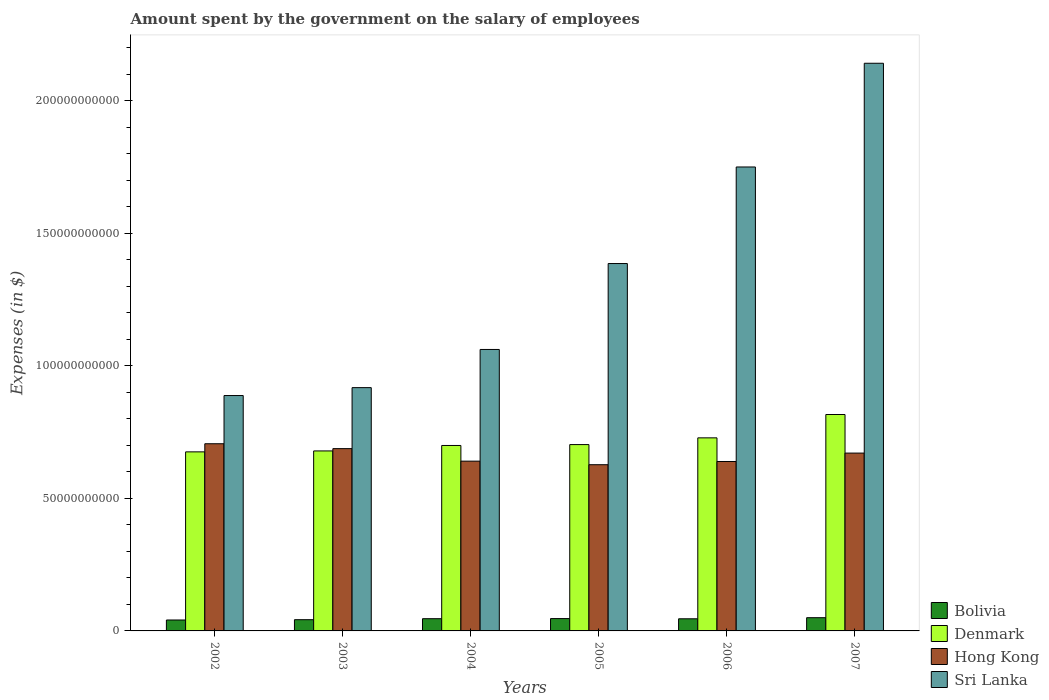Are the number of bars per tick equal to the number of legend labels?
Provide a short and direct response. Yes. Are the number of bars on each tick of the X-axis equal?
Your answer should be compact. Yes. How many bars are there on the 4th tick from the left?
Offer a very short reply. 4. How many bars are there on the 2nd tick from the right?
Offer a very short reply. 4. What is the label of the 5th group of bars from the left?
Your answer should be compact. 2006. In how many cases, is the number of bars for a given year not equal to the number of legend labels?
Give a very brief answer. 0. What is the amount spent on the salary of employees by the government in Denmark in 2006?
Make the answer very short. 7.28e+1. Across all years, what is the maximum amount spent on the salary of employees by the government in Bolivia?
Your response must be concise. 4.99e+09. Across all years, what is the minimum amount spent on the salary of employees by the government in Bolivia?
Your answer should be compact. 4.12e+09. What is the total amount spent on the salary of employees by the government in Hong Kong in the graph?
Keep it short and to the point. 3.97e+11. What is the difference between the amount spent on the salary of employees by the government in Bolivia in 2002 and that in 2007?
Give a very brief answer. -8.69e+08. What is the difference between the amount spent on the salary of employees by the government in Denmark in 2005 and the amount spent on the salary of employees by the government in Sri Lanka in 2004?
Your response must be concise. -3.59e+1. What is the average amount spent on the salary of employees by the government in Hong Kong per year?
Provide a short and direct response. 6.62e+1. In the year 2003, what is the difference between the amount spent on the salary of employees by the government in Denmark and amount spent on the salary of employees by the government in Hong Kong?
Ensure brevity in your answer.  -8.68e+08. In how many years, is the amount spent on the salary of employees by the government in Sri Lanka greater than 120000000000 $?
Offer a very short reply. 3. What is the ratio of the amount spent on the salary of employees by the government in Sri Lanka in 2003 to that in 2007?
Your answer should be compact. 0.43. Is the amount spent on the salary of employees by the government in Denmark in 2003 less than that in 2005?
Keep it short and to the point. Yes. What is the difference between the highest and the second highest amount spent on the salary of employees by the government in Denmark?
Give a very brief answer. 8.81e+09. What is the difference between the highest and the lowest amount spent on the salary of employees by the government in Hong Kong?
Keep it short and to the point. 7.91e+09. Is it the case that in every year, the sum of the amount spent on the salary of employees by the government in Sri Lanka and amount spent on the salary of employees by the government in Denmark is greater than the sum of amount spent on the salary of employees by the government in Bolivia and amount spent on the salary of employees by the government in Hong Kong?
Give a very brief answer. Yes. What does the 3rd bar from the right in 2003 represents?
Offer a terse response. Denmark. Is it the case that in every year, the sum of the amount spent on the salary of employees by the government in Bolivia and amount spent on the salary of employees by the government in Denmark is greater than the amount spent on the salary of employees by the government in Sri Lanka?
Make the answer very short. No. How many bars are there?
Offer a terse response. 24. Does the graph contain any zero values?
Your answer should be compact. No. Does the graph contain grids?
Provide a short and direct response. No. How many legend labels are there?
Offer a very short reply. 4. What is the title of the graph?
Your answer should be compact. Amount spent by the government on the salary of employees. What is the label or title of the Y-axis?
Keep it short and to the point. Expenses (in $). What is the Expenses (in $) of Bolivia in 2002?
Keep it short and to the point. 4.12e+09. What is the Expenses (in $) in Denmark in 2002?
Make the answer very short. 6.76e+1. What is the Expenses (in $) in Hong Kong in 2002?
Make the answer very short. 7.06e+1. What is the Expenses (in $) of Sri Lanka in 2002?
Your answer should be very brief. 8.88e+1. What is the Expenses (in $) in Bolivia in 2003?
Your answer should be compact. 4.24e+09. What is the Expenses (in $) of Denmark in 2003?
Provide a succinct answer. 6.79e+1. What is the Expenses (in $) in Hong Kong in 2003?
Your answer should be compact. 6.88e+1. What is the Expenses (in $) of Sri Lanka in 2003?
Your response must be concise. 9.18e+1. What is the Expenses (in $) in Bolivia in 2004?
Give a very brief answer. 4.61e+09. What is the Expenses (in $) of Denmark in 2004?
Ensure brevity in your answer.  7.00e+1. What is the Expenses (in $) of Hong Kong in 2004?
Ensure brevity in your answer.  6.41e+1. What is the Expenses (in $) in Sri Lanka in 2004?
Provide a succinct answer. 1.06e+11. What is the Expenses (in $) of Bolivia in 2005?
Your answer should be compact. 4.65e+09. What is the Expenses (in $) in Denmark in 2005?
Offer a terse response. 7.03e+1. What is the Expenses (in $) in Hong Kong in 2005?
Offer a terse response. 6.27e+1. What is the Expenses (in $) of Sri Lanka in 2005?
Give a very brief answer. 1.39e+11. What is the Expenses (in $) of Bolivia in 2006?
Offer a terse response. 4.57e+09. What is the Expenses (in $) of Denmark in 2006?
Offer a terse response. 7.28e+1. What is the Expenses (in $) in Hong Kong in 2006?
Provide a short and direct response. 6.39e+1. What is the Expenses (in $) in Sri Lanka in 2006?
Provide a succinct answer. 1.75e+11. What is the Expenses (in $) in Bolivia in 2007?
Your answer should be compact. 4.99e+09. What is the Expenses (in $) of Denmark in 2007?
Provide a short and direct response. 8.16e+1. What is the Expenses (in $) in Hong Kong in 2007?
Make the answer very short. 6.71e+1. What is the Expenses (in $) of Sri Lanka in 2007?
Provide a short and direct response. 2.14e+11. Across all years, what is the maximum Expenses (in $) in Bolivia?
Offer a terse response. 4.99e+09. Across all years, what is the maximum Expenses (in $) of Denmark?
Your answer should be compact. 8.16e+1. Across all years, what is the maximum Expenses (in $) in Hong Kong?
Your answer should be compact. 7.06e+1. Across all years, what is the maximum Expenses (in $) of Sri Lanka?
Offer a terse response. 2.14e+11. Across all years, what is the minimum Expenses (in $) of Bolivia?
Give a very brief answer. 4.12e+09. Across all years, what is the minimum Expenses (in $) in Denmark?
Ensure brevity in your answer.  6.76e+1. Across all years, what is the minimum Expenses (in $) in Hong Kong?
Offer a terse response. 6.27e+1. Across all years, what is the minimum Expenses (in $) of Sri Lanka?
Give a very brief answer. 8.88e+1. What is the total Expenses (in $) in Bolivia in the graph?
Your response must be concise. 2.72e+1. What is the total Expenses (in $) of Denmark in the graph?
Offer a very short reply. 4.30e+11. What is the total Expenses (in $) in Hong Kong in the graph?
Your answer should be very brief. 3.97e+11. What is the total Expenses (in $) in Sri Lanka in the graph?
Ensure brevity in your answer.  8.15e+11. What is the difference between the Expenses (in $) in Bolivia in 2002 and that in 2003?
Your answer should be compact. -1.16e+08. What is the difference between the Expenses (in $) of Denmark in 2002 and that in 2003?
Your answer should be compact. -3.53e+08. What is the difference between the Expenses (in $) of Hong Kong in 2002 and that in 2003?
Offer a terse response. 1.84e+09. What is the difference between the Expenses (in $) in Sri Lanka in 2002 and that in 2003?
Offer a terse response. -2.98e+09. What is the difference between the Expenses (in $) of Bolivia in 2002 and that in 2004?
Provide a short and direct response. -4.90e+08. What is the difference between the Expenses (in $) of Denmark in 2002 and that in 2004?
Keep it short and to the point. -2.41e+09. What is the difference between the Expenses (in $) of Hong Kong in 2002 and that in 2004?
Provide a succinct answer. 6.56e+09. What is the difference between the Expenses (in $) in Sri Lanka in 2002 and that in 2004?
Offer a very short reply. -1.74e+1. What is the difference between the Expenses (in $) in Bolivia in 2002 and that in 2005?
Ensure brevity in your answer.  -5.32e+08. What is the difference between the Expenses (in $) of Denmark in 2002 and that in 2005?
Your answer should be very brief. -2.75e+09. What is the difference between the Expenses (in $) in Hong Kong in 2002 and that in 2005?
Your answer should be very brief. 7.91e+09. What is the difference between the Expenses (in $) of Sri Lanka in 2002 and that in 2005?
Provide a succinct answer. -4.98e+1. What is the difference between the Expenses (in $) in Bolivia in 2002 and that in 2006?
Your response must be concise. -4.53e+08. What is the difference between the Expenses (in $) of Denmark in 2002 and that in 2006?
Provide a short and direct response. -5.29e+09. What is the difference between the Expenses (in $) in Hong Kong in 2002 and that in 2006?
Offer a very short reply. 6.70e+09. What is the difference between the Expenses (in $) of Sri Lanka in 2002 and that in 2006?
Ensure brevity in your answer.  -8.62e+1. What is the difference between the Expenses (in $) of Bolivia in 2002 and that in 2007?
Offer a terse response. -8.69e+08. What is the difference between the Expenses (in $) of Denmark in 2002 and that in 2007?
Your response must be concise. -1.41e+1. What is the difference between the Expenses (in $) of Hong Kong in 2002 and that in 2007?
Ensure brevity in your answer.  3.52e+09. What is the difference between the Expenses (in $) in Sri Lanka in 2002 and that in 2007?
Your answer should be very brief. -1.25e+11. What is the difference between the Expenses (in $) in Bolivia in 2003 and that in 2004?
Your answer should be compact. -3.74e+08. What is the difference between the Expenses (in $) of Denmark in 2003 and that in 2004?
Your response must be concise. -2.06e+09. What is the difference between the Expenses (in $) of Hong Kong in 2003 and that in 2004?
Your response must be concise. 4.72e+09. What is the difference between the Expenses (in $) of Sri Lanka in 2003 and that in 2004?
Ensure brevity in your answer.  -1.44e+1. What is the difference between the Expenses (in $) in Bolivia in 2003 and that in 2005?
Offer a very short reply. -4.16e+08. What is the difference between the Expenses (in $) of Denmark in 2003 and that in 2005?
Your answer should be very brief. -2.39e+09. What is the difference between the Expenses (in $) of Hong Kong in 2003 and that in 2005?
Offer a terse response. 6.07e+09. What is the difference between the Expenses (in $) in Sri Lanka in 2003 and that in 2005?
Provide a succinct answer. -4.68e+1. What is the difference between the Expenses (in $) in Bolivia in 2003 and that in 2006?
Offer a very short reply. -3.37e+08. What is the difference between the Expenses (in $) of Denmark in 2003 and that in 2006?
Make the answer very short. -4.93e+09. What is the difference between the Expenses (in $) of Hong Kong in 2003 and that in 2006?
Ensure brevity in your answer.  4.85e+09. What is the difference between the Expenses (in $) in Sri Lanka in 2003 and that in 2006?
Provide a short and direct response. -8.32e+1. What is the difference between the Expenses (in $) in Bolivia in 2003 and that in 2007?
Provide a short and direct response. -7.53e+08. What is the difference between the Expenses (in $) of Denmark in 2003 and that in 2007?
Offer a very short reply. -1.37e+1. What is the difference between the Expenses (in $) in Hong Kong in 2003 and that in 2007?
Offer a terse response. 1.68e+09. What is the difference between the Expenses (in $) in Sri Lanka in 2003 and that in 2007?
Offer a terse response. -1.22e+11. What is the difference between the Expenses (in $) in Bolivia in 2004 and that in 2005?
Your answer should be compact. -4.21e+07. What is the difference between the Expenses (in $) in Denmark in 2004 and that in 2005?
Offer a very short reply. -3.33e+08. What is the difference between the Expenses (in $) in Hong Kong in 2004 and that in 2005?
Your answer should be compact. 1.35e+09. What is the difference between the Expenses (in $) in Sri Lanka in 2004 and that in 2005?
Give a very brief answer. -3.24e+1. What is the difference between the Expenses (in $) of Bolivia in 2004 and that in 2006?
Ensure brevity in your answer.  3.71e+07. What is the difference between the Expenses (in $) in Denmark in 2004 and that in 2006?
Provide a succinct answer. -2.87e+09. What is the difference between the Expenses (in $) of Hong Kong in 2004 and that in 2006?
Your answer should be very brief. 1.32e+08. What is the difference between the Expenses (in $) in Sri Lanka in 2004 and that in 2006?
Ensure brevity in your answer.  -6.88e+1. What is the difference between the Expenses (in $) in Bolivia in 2004 and that in 2007?
Ensure brevity in your answer.  -3.79e+08. What is the difference between the Expenses (in $) of Denmark in 2004 and that in 2007?
Give a very brief answer. -1.17e+1. What is the difference between the Expenses (in $) in Hong Kong in 2004 and that in 2007?
Provide a succinct answer. -3.04e+09. What is the difference between the Expenses (in $) in Sri Lanka in 2004 and that in 2007?
Your answer should be very brief. -1.08e+11. What is the difference between the Expenses (in $) in Bolivia in 2005 and that in 2006?
Make the answer very short. 7.92e+07. What is the difference between the Expenses (in $) of Denmark in 2005 and that in 2006?
Offer a terse response. -2.54e+09. What is the difference between the Expenses (in $) of Hong Kong in 2005 and that in 2006?
Provide a short and direct response. -1.22e+09. What is the difference between the Expenses (in $) of Sri Lanka in 2005 and that in 2006?
Give a very brief answer. -3.64e+1. What is the difference between the Expenses (in $) in Bolivia in 2005 and that in 2007?
Keep it short and to the point. -3.37e+08. What is the difference between the Expenses (in $) of Denmark in 2005 and that in 2007?
Offer a very short reply. -1.13e+1. What is the difference between the Expenses (in $) in Hong Kong in 2005 and that in 2007?
Offer a terse response. -4.39e+09. What is the difference between the Expenses (in $) of Sri Lanka in 2005 and that in 2007?
Provide a short and direct response. -7.56e+1. What is the difference between the Expenses (in $) of Bolivia in 2006 and that in 2007?
Make the answer very short. -4.16e+08. What is the difference between the Expenses (in $) of Denmark in 2006 and that in 2007?
Offer a very short reply. -8.81e+09. What is the difference between the Expenses (in $) of Hong Kong in 2006 and that in 2007?
Your answer should be very brief. -3.17e+09. What is the difference between the Expenses (in $) of Sri Lanka in 2006 and that in 2007?
Keep it short and to the point. -3.91e+1. What is the difference between the Expenses (in $) in Bolivia in 2002 and the Expenses (in $) in Denmark in 2003?
Provide a succinct answer. -6.38e+1. What is the difference between the Expenses (in $) of Bolivia in 2002 and the Expenses (in $) of Hong Kong in 2003?
Your answer should be very brief. -6.47e+1. What is the difference between the Expenses (in $) in Bolivia in 2002 and the Expenses (in $) in Sri Lanka in 2003?
Provide a succinct answer. -8.77e+1. What is the difference between the Expenses (in $) in Denmark in 2002 and the Expenses (in $) in Hong Kong in 2003?
Keep it short and to the point. -1.22e+09. What is the difference between the Expenses (in $) of Denmark in 2002 and the Expenses (in $) of Sri Lanka in 2003?
Provide a succinct answer. -2.42e+1. What is the difference between the Expenses (in $) in Hong Kong in 2002 and the Expenses (in $) in Sri Lanka in 2003?
Keep it short and to the point. -2.12e+1. What is the difference between the Expenses (in $) of Bolivia in 2002 and the Expenses (in $) of Denmark in 2004?
Offer a terse response. -6.58e+1. What is the difference between the Expenses (in $) of Bolivia in 2002 and the Expenses (in $) of Hong Kong in 2004?
Your answer should be very brief. -5.99e+1. What is the difference between the Expenses (in $) of Bolivia in 2002 and the Expenses (in $) of Sri Lanka in 2004?
Offer a terse response. -1.02e+11. What is the difference between the Expenses (in $) in Denmark in 2002 and the Expenses (in $) in Hong Kong in 2004?
Make the answer very short. 3.50e+09. What is the difference between the Expenses (in $) of Denmark in 2002 and the Expenses (in $) of Sri Lanka in 2004?
Provide a succinct answer. -3.86e+1. What is the difference between the Expenses (in $) of Hong Kong in 2002 and the Expenses (in $) of Sri Lanka in 2004?
Provide a short and direct response. -3.56e+1. What is the difference between the Expenses (in $) in Bolivia in 2002 and the Expenses (in $) in Denmark in 2005?
Provide a succinct answer. -6.62e+1. What is the difference between the Expenses (in $) in Bolivia in 2002 and the Expenses (in $) in Hong Kong in 2005?
Keep it short and to the point. -5.86e+1. What is the difference between the Expenses (in $) in Bolivia in 2002 and the Expenses (in $) in Sri Lanka in 2005?
Your answer should be very brief. -1.34e+11. What is the difference between the Expenses (in $) of Denmark in 2002 and the Expenses (in $) of Hong Kong in 2005?
Offer a terse response. 4.85e+09. What is the difference between the Expenses (in $) in Denmark in 2002 and the Expenses (in $) in Sri Lanka in 2005?
Your answer should be compact. -7.11e+1. What is the difference between the Expenses (in $) in Hong Kong in 2002 and the Expenses (in $) in Sri Lanka in 2005?
Offer a terse response. -6.80e+1. What is the difference between the Expenses (in $) in Bolivia in 2002 and the Expenses (in $) in Denmark in 2006?
Keep it short and to the point. -6.87e+1. What is the difference between the Expenses (in $) in Bolivia in 2002 and the Expenses (in $) in Hong Kong in 2006?
Ensure brevity in your answer.  -5.98e+1. What is the difference between the Expenses (in $) in Bolivia in 2002 and the Expenses (in $) in Sri Lanka in 2006?
Offer a very short reply. -1.71e+11. What is the difference between the Expenses (in $) in Denmark in 2002 and the Expenses (in $) in Hong Kong in 2006?
Provide a short and direct response. 3.63e+09. What is the difference between the Expenses (in $) in Denmark in 2002 and the Expenses (in $) in Sri Lanka in 2006?
Offer a very short reply. -1.07e+11. What is the difference between the Expenses (in $) in Hong Kong in 2002 and the Expenses (in $) in Sri Lanka in 2006?
Make the answer very short. -1.04e+11. What is the difference between the Expenses (in $) of Bolivia in 2002 and the Expenses (in $) of Denmark in 2007?
Your response must be concise. -7.75e+1. What is the difference between the Expenses (in $) of Bolivia in 2002 and the Expenses (in $) of Hong Kong in 2007?
Offer a terse response. -6.30e+1. What is the difference between the Expenses (in $) in Bolivia in 2002 and the Expenses (in $) in Sri Lanka in 2007?
Provide a short and direct response. -2.10e+11. What is the difference between the Expenses (in $) in Denmark in 2002 and the Expenses (in $) in Hong Kong in 2007?
Your answer should be very brief. 4.61e+08. What is the difference between the Expenses (in $) in Denmark in 2002 and the Expenses (in $) in Sri Lanka in 2007?
Offer a terse response. -1.47e+11. What is the difference between the Expenses (in $) in Hong Kong in 2002 and the Expenses (in $) in Sri Lanka in 2007?
Your answer should be compact. -1.44e+11. What is the difference between the Expenses (in $) in Bolivia in 2003 and the Expenses (in $) in Denmark in 2004?
Offer a very short reply. -6.57e+1. What is the difference between the Expenses (in $) of Bolivia in 2003 and the Expenses (in $) of Hong Kong in 2004?
Ensure brevity in your answer.  -5.98e+1. What is the difference between the Expenses (in $) in Bolivia in 2003 and the Expenses (in $) in Sri Lanka in 2004?
Offer a very short reply. -1.02e+11. What is the difference between the Expenses (in $) of Denmark in 2003 and the Expenses (in $) of Hong Kong in 2004?
Offer a very short reply. 3.85e+09. What is the difference between the Expenses (in $) of Denmark in 2003 and the Expenses (in $) of Sri Lanka in 2004?
Provide a succinct answer. -3.83e+1. What is the difference between the Expenses (in $) in Hong Kong in 2003 and the Expenses (in $) in Sri Lanka in 2004?
Give a very brief answer. -3.74e+1. What is the difference between the Expenses (in $) in Bolivia in 2003 and the Expenses (in $) in Denmark in 2005?
Provide a short and direct response. -6.61e+1. What is the difference between the Expenses (in $) in Bolivia in 2003 and the Expenses (in $) in Hong Kong in 2005?
Ensure brevity in your answer.  -5.85e+1. What is the difference between the Expenses (in $) in Bolivia in 2003 and the Expenses (in $) in Sri Lanka in 2005?
Offer a terse response. -1.34e+11. What is the difference between the Expenses (in $) of Denmark in 2003 and the Expenses (in $) of Hong Kong in 2005?
Provide a short and direct response. 5.20e+09. What is the difference between the Expenses (in $) in Denmark in 2003 and the Expenses (in $) in Sri Lanka in 2005?
Ensure brevity in your answer.  -7.07e+1. What is the difference between the Expenses (in $) in Hong Kong in 2003 and the Expenses (in $) in Sri Lanka in 2005?
Offer a terse response. -6.98e+1. What is the difference between the Expenses (in $) in Bolivia in 2003 and the Expenses (in $) in Denmark in 2006?
Provide a short and direct response. -6.86e+1. What is the difference between the Expenses (in $) in Bolivia in 2003 and the Expenses (in $) in Hong Kong in 2006?
Give a very brief answer. -5.97e+1. What is the difference between the Expenses (in $) in Bolivia in 2003 and the Expenses (in $) in Sri Lanka in 2006?
Ensure brevity in your answer.  -1.71e+11. What is the difference between the Expenses (in $) of Denmark in 2003 and the Expenses (in $) of Hong Kong in 2006?
Give a very brief answer. 3.98e+09. What is the difference between the Expenses (in $) of Denmark in 2003 and the Expenses (in $) of Sri Lanka in 2006?
Provide a succinct answer. -1.07e+11. What is the difference between the Expenses (in $) in Hong Kong in 2003 and the Expenses (in $) in Sri Lanka in 2006?
Offer a terse response. -1.06e+11. What is the difference between the Expenses (in $) of Bolivia in 2003 and the Expenses (in $) of Denmark in 2007?
Offer a terse response. -7.74e+1. What is the difference between the Expenses (in $) in Bolivia in 2003 and the Expenses (in $) in Hong Kong in 2007?
Offer a very short reply. -6.29e+1. What is the difference between the Expenses (in $) of Bolivia in 2003 and the Expenses (in $) of Sri Lanka in 2007?
Give a very brief answer. -2.10e+11. What is the difference between the Expenses (in $) of Denmark in 2003 and the Expenses (in $) of Hong Kong in 2007?
Provide a short and direct response. 8.14e+08. What is the difference between the Expenses (in $) in Denmark in 2003 and the Expenses (in $) in Sri Lanka in 2007?
Your response must be concise. -1.46e+11. What is the difference between the Expenses (in $) of Hong Kong in 2003 and the Expenses (in $) of Sri Lanka in 2007?
Your answer should be very brief. -1.45e+11. What is the difference between the Expenses (in $) of Bolivia in 2004 and the Expenses (in $) of Denmark in 2005?
Keep it short and to the point. -6.57e+1. What is the difference between the Expenses (in $) of Bolivia in 2004 and the Expenses (in $) of Hong Kong in 2005?
Your answer should be very brief. -5.81e+1. What is the difference between the Expenses (in $) of Bolivia in 2004 and the Expenses (in $) of Sri Lanka in 2005?
Offer a very short reply. -1.34e+11. What is the difference between the Expenses (in $) of Denmark in 2004 and the Expenses (in $) of Hong Kong in 2005?
Offer a terse response. 7.26e+09. What is the difference between the Expenses (in $) in Denmark in 2004 and the Expenses (in $) in Sri Lanka in 2005?
Ensure brevity in your answer.  -6.86e+1. What is the difference between the Expenses (in $) in Hong Kong in 2004 and the Expenses (in $) in Sri Lanka in 2005?
Offer a very short reply. -7.46e+1. What is the difference between the Expenses (in $) of Bolivia in 2004 and the Expenses (in $) of Denmark in 2006?
Your response must be concise. -6.82e+1. What is the difference between the Expenses (in $) of Bolivia in 2004 and the Expenses (in $) of Hong Kong in 2006?
Provide a short and direct response. -5.93e+1. What is the difference between the Expenses (in $) of Bolivia in 2004 and the Expenses (in $) of Sri Lanka in 2006?
Provide a short and direct response. -1.70e+11. What is the difference between the Expenses (in $) of Denmark in 2004 and the Expenses (in $) of Hong Kong in 2006?
Keep it short and to the point. 6.04e+09. What is the difference between the Expenses (in $) in Denmark in 2004 and the Expenses (in $) in Sri Lanka in 2006?
Offer a very short reply. -1.05e+11. What is the difference between the Expenses (in $) in Hong Kong in 2004 and the Expenses (in $) in Sri Lanka in 2006?
Offer a terse response. -1.11e+11. What is the difference between the Expenses (in $) in Bolivia in 2004 and the Expenses (in $) in Denmark in 2007?
Offer a very short reply. -7.70e+1. What is the difference between the Expenses (in $) in Bolivia in 2004 and the Expenses (in $) in Hong Kong in 2007?
Your response must be concise. -6.25e+1. What is the difference between the Expenses (in $) of Bolivia in 2004 and the Expenses (in $) of Sri Lanka in 2007?
Provide a short and direct response. -2.10e+11. What is the difference between the Expenses (in $) of Denmark in 2004 and the Expenses (in $) of Hong Kong in 2007?
Ensure brevity in your answer.  2.87e+09. What is the difference between the Expenses (in $) of Denmark in 2004 and the Expenses (in $) of Sri Lanka in 2007?
Provide a short and direct response. -1.44e+11. What is the difference between the Expenses (in $) in Hong Kong in 2004 and the Expenses (in $) in Sri Lanka in 2007?
Give a very brief answer. -1.50e+11. What is the difference between the Expenses (in $) in Bolivia in 2005 and the Expenses (in $) in Denmark in 2006?
Offer a terse response. -6.82e+1. What is the difference between the Expenses (in $) of Bolivia in 2005 and the Expenses (in $) of Hong Kong in 2006?
Ensure brevity in your answer.  -5.93e+1. What is the difference between the Expenses (in $) in Bolivia in 2005 and the Expenses (in $) in Sri Lanka in 2006?
Offer a terse response. -1.70e+11. What is the difference between the Expenses (in $) of Denmark in 2005 and the Expenses (in $) of Hong Kong in 2006?
Provide a succinct answer. 6.38e+09. What is the difference between the Expenses (in $) of Denmark in 2005 and the Expenses (in $) of Sri Lanka in 2006?
Ensure brevity in your answer.  -1.05e+11. What is the difference between the Expenses (in $) in Hong Kong in 2005 and the Expenses (in $) in Sri Lanka in 2006?
Ensure brevity in your answer.  -1.12e+11. What is the difference between the Expenses (in $) in Bolivia in 2005 and the Expenses (in $) in Denmark in 2007?
Offer a terse response. -7.70e+1. What is the difference between the Expenses (in $) of Bolivia in 2005 and the Expenses (in $) of Hong Kong in 2007?
Provide a short and direct response. -6.24e+1. What is the difference between the Expenses (in $) of Bolivia in 2005 and the Expenses (in $) of Sri Lanka in 2007?
Your response must be concise. -2.10e+11. What is the difference between the Expenses (in $) in Denmark in 2005 and the Expenses (in $) in Hong Kong in 2007?
Keep it short and to the point. 3.21e+09. What is the difference between the Expenses (in $) in Denmark in 2005 and the Expenses (in $) in Sri Lanka in 2007?
Keep it short and to the point. -1.44e+11. What is the difference between the Expenses (in $) in Hong Kong in 2005 and the Expenses (in $) in Sri Lanka in 2007?
Keep it short and to the point. -1.51e+11. What is the difference between the Expenses (in $) in Bolivia in 2006 and the Expenses (in $) in Denmark in 2007?
Offer a very short reply. -7.71e+1. What is the difference between the Expenses (in $) of Bolivia in 2006 and the Expenses (in $) of Hong Kong in 2007?
Make the answer very short. -6.25e+1. What is the difference between the Expenses (in $) of Bolivia in 2006 and the Expenses (in $) of Sri Lanka in 2007?
Offer a very short reply. -2.10e+11. What is the difference between the Expenses (in $) in Denmark in 2006 and the Expenses (in $) in Hong Kong in 2007?
Your response must be concise. 5.75e+09. What is the difference between the Expenses (in $) of Denmark in 2006 and the Expenses (in $) of Sri Lanka in 2007?
Your response must be concise. -1.41e+11. What is the difference between the Expenses (in $) in Hong Kong in 2006 and the Expenses (in $) in Sri Lanka in 2007?
Offer a very short reply. -1.50e+11. What is the average Expenses (in $) of Bolivia per year?
Give a very brief answer. 4.53e+09. What is the average Expenses (in $) in Denmark per year?
Make the answer very short. 7.17e+1. What is the average Expenses (in $) of Hong Kong per year?
Your answer should be compact. 6.62e+1. What is the average Expenses (in $) of Sri Lanka per year?
Keep it short and to the point. 1.36e+11. In the year 2002, what is the difference between the Expenses (in $) in Bolivia and Expenses (in $) in Denmark?
Ensure brevity in your answer.  -6.34e+1. In the year 2002, what is the difference between the Expenses (in $) in Bolivia and Expenses (in $) in Hong Kong?
Provide a short and direct response. -6.65e+1. In the year 2002, what is the difference between the Expenses (in $) of Bolivia and Expenses (in $) of Sri Lanka?
Your response must be concise. -8.47e+1. In the year 2002, what is the difference between the Expenses (in $) of Denmark and Expenses (in $) of Hong Kong?
Make the answer very short. -3.06e+09. In the year 2002, what is the difference between the Expenses (in $) of Denmark and Expenses (in $) of Sri Lanka?
Provide a succinct answer. -2.13e+1. In the year 2002, what is the difference between the Expenses (in $) of Hong Kong and Expenses (in $) of Sri Lanka?
Your answer should be compact. -1.82e+1. In the year 2003, what is the difference between the Expenses (in $) of Bolivia and Expenses (in $) of Denmark?
Keep it short and to the point. -6.37e+1. In the year 2003, what is the difference between the Expenses (in $) in Bolivia and Expenses (in $) in Hong Kong?
Keep it short and to the point. -6.45e+1. In the year 2003, what is the difference between the Expenses (in $) in Bolivia and Expenses (in $) in Sri Lanka?
Ensure brevity in your answer.  -8.75e+1. In the year 2003, what is the difference between the Expenses (in $) of Denmark and Expenses (in $) of Hong Kong?
Your response must be concise. -8.68e+08. In the year 2003, what is the difference between the Expenses (in $) in Denmark and Expenses (in $) in Sri Lanka?
Offer a very short reply. -2.39e+1. In the year 2003, what is the difference between the Expenses (in $) of Hong Kong and Expenses (in $) of Sri Lanka?
Offer a terse response. -2.30e+1. In the year 2004, what is the difference between the Expenses (in $) in Bolivia and Expenses (in $) in Denmark?
Keep it short and to the point. -6.54e+1. In the year 2004, what is the difference between the Expenses (in $) of Bolivia and Expenses (in $) of Hong Kong?
Provide a succinct answer. -5.94e+1. In the year 2004, what is the difference between the Expenses (in $) in Bolivia and Expenses (in $) in Sri Lanka?
Make the answer very short. -1.02e+11. In the year 2004, what is the difference between the Expenses (in $) in Denmark and Expenses (in $) in Hong Kong?
Offer a terse response. 5.91e+09. In the year 2004, what is the difference between the Expenses (in $) of Denmark and Expenses (in $) of Sri Lanka?
Your answer should be very brief. -3.62e+1. In the year 2004, what is the difference between the Expenses (in $) in Hong Kong and Expenses (in $) in Sri Lanka?
Make the answer very short. -4.21e+1. In the year 2005, what is the difference between the Expenses (in $) of Bolivia and Expenses (in $) of Denmark?
Your response must be concise. -6.56e+1. In the year 2005, what is the difference between the Expenses (in $) in Bolivia and Expenses (in $) in Hong Kong?
Keep it short and to the point. -5.80e+1. In the year 2005, what is the difference between the Expenses (in $) in Bolivia and Expenses (in $) in Sri Lanka?
Ensure brevity in your answer.  -1.34e+11. In the year 2005, what is the difference between the Expenses (in $) of Denmark and Expenses (in $) of Hong Kong?
Keep it short and to the point. 7.59e+09. In the year 2005, what is the difference between the Expenses (in $) in Denmark and Expenses (in $) in Sri Lanka?
Ensure brevity in your answer.  -6.83e+1. In the year 2005, what is the difference between the Expenses (in $) of Hong Kong and Expenses (in $) of Sri Lanka?
Your answer should be very brief. -7.59e+1. In the year 2006, what is the difference between the Expenses (in $) in Bolivia and Expenses (in $) in Denmark?
Offer a very short reply. -6.83e+1. In the year 2006, what is the difference between the Expenses (in $) of Bolivia and Expenses (in $) of Hong Kong?
Your answer should be very brief. -5.93e+1. In the year 2006, what is the difference between the Expenses (in $) of Bolivia and Expenses (in $) of Sri Lanka?
Offer a terse response. -1.70e+11. In the year 2006, what is the difference between the Expenses (in $) of Denmark and Expenses (in $) of Hong Kong?
Provide a short and direct response. 8.92e+09. In the year 2006, what is the difference between the Expenses (in $) of Denmark and Expenses (in $) of Sri Lanka?
Ensure brevity in your answer.  -1.02e+11. In the year 2006, what is the difference between the Expenses (in $) in Hong Kong and Expenses (in $) in Sri Lanka?
Give a very brief answer. -1.11e+11. In the year 2007, what is the difference between the Expenses (in $) of Bolivia and Expenses (in $) of Denmark?
Your answer should be compact. -7.67e+1. In the year 2007, what is the difference between the Expenses (in $) in Bolivia and Expenses (in $) in Hong Kong?
Keep it short and to the point. -6.21e+1. In the year 2007, what is the difference between the Expenses (in $) in Bolivia and Expenses (in $) in Sri Lanka?
Your response must be concise. -2.09e+11. In the year 2007, what is the difference between the Expenses (in $) in Denmark and Expenses (in $) in Hong Kong?
Provide a succinct answer. 1.46e+1. In the year 2007, what is the difference between the Expenses (in $) in Denmark and Expenses (in $) in Sri Lanka?
Ensure brevity in your answer.  -1.33e+11. In the year 2007, what is the difference between the Expenses (in $) in Hong Kong and Expenses (in $) in Sri Lanka?
Your response must be concise. -1.47e+11. What is the ratio of the Expenses (in $) of Bolivia in 2002 to that in 2003?
Your answer should be very brief. 0.97. What is the ratio of the Expenses (in $) in Denmark in 2002 to that in 2003?
Provide a succinct answer. 0.99. What is the ratio of the Expenses (in $) in Hong Kong in 2002 to that in 2003?
Your answer should be very brief. 1.03. What is the ratio of the Expenses (in $) in Sri Lanka in 2002 to that in 2003?
Keep it short and to the point. 0.97. What is the ratio of the Expenses (in $) in Bolivia in 2002 to that in 2004?
Your answer should be very brief. 0.89. What is the ratio of the Expenses (in $) in Denmark in 2002 to that in 2004?
Your response must be concise. 0.97. What is the ratio of the Expenses (in $) in Hong Kong in 2002 to that in 2004?
Ensure brevity in your answer.  1.1. What is the ratio of the Expenses (in $) of Sri Lanka in 2002 to that in 2004?
Keep it short and to the point. 0.84. What is the ratio of the Expenses (in $) of Bolivia in 2002 to that in 2005?
Provide a short and direct response. 0.89. What is the ratio of the Expenses (in $) of Denmark in 2002 to that in 2005?
Ensure brevity in your answer.  0.96. What is the ratio of the Expenses (in $) of Hong Kong in 2002 to that in 2005?
Offer a terse response. 1.13. What is the ratio of the Expenses (in $) of Sri Lanka in 2002 to that in 2005?
Ensure brevity in your answer.  0.64. What is the ratio of the Expenses (in $) in Bolivia in 2002 to that in 2006?
Provide a succinct answer. 0.9. What is the ratio of the Expenses (in $) of Denmark in 2002 to that in 2006?
Ensure brevity in your answer.  0.93. What is the ratio of the Expenses (in $) in Hong Kong in 2002 to that in 2006?
Your answer should be compact. 1.1. What is the ratio of the Expenses (in $) in Sri Lanka in 2002 to that in 2006?
Give a very brief answer. 0.51. What is the ratio of the Expenses (in $) of Bolivia in 2002 to that in 2007?
Ensure brevity in your answer.  0.83. What is the ratio of the Expenses (in $) in Denmark in 2002 to that in 2007?
Provide a succinct answer. 0.83. What is the ratio of the Expenses (in $) of Hong Kong in 2002 to that in 2007?
Keep it short and to the point. 1.05. What is the ratio of the Expenses (in $) in Sri Lanka in 2002 to that in 2007?
Your answer should be compact. 0.41. What is the ratio of the Expenses (in $) of Bolivia in 2003 to that in 2004?
Provide a short and direct response. 0.92. What is the ratio of the Expenses (in $) of Denmark in 2003 to that in 2004?
Offer a terse response. 0.97. What is the ratio of the Expenses (in $) of Hong Kong in 2003 to that in 2004?
Provide a short and direct response. 1.07. What is the ratio of the Expenses (in $) in Sri Lanka in 2003 to that in 2004?
Provide a succinct answer. 0.86. What is the ratio of the Expenses (in $) in Bolivia in 2003 to that in 2005?
Provide a short and direct response. 0.91. What is the ratio of the Expenses (in $) in Hong Kong in 2003 to that in 2005?
Make the answer very short. 1.1. What is the ratio of the Expenses (in $) in Sri Lanka in 2003 to that in 2005?
Ensure brevity in your answer.  0.66. What is the ratio of the Expenses (in $) of Bolivia in 2003 to that in 2006?
Provide a short and direct response. 0.93. What is the ratio of the Expenses (in $) of Denmark in 2003 to that in 2006?
Keep it short and to the point. 0.93. What is the ratio of the Expenses (in $) in Hong Kong in 2003 to that in 2006?
Make the answer very short. 1.08. What is the ratio of the Expenses (in $) in Sri Lanka in 2003 to that in 2006?
Provide a short and direct response. 0.52. What is the ratio of the Expenses (in $) in Bolivia in 2003 to that in 2007?
Make the answer very short. 0.85. What is the ratio of the Expenses (in $) of Denmark in 2003 to that in 2007?
Provide a short and direct response. 0.83. What is the ratio of the Expenses (in $) in Hong Kong in 2003 to that in 2007?
Your answer should be compact. 1.03. What is the ratio of the Expenses (in $) in Sri Lanka in 2003 to that in 2007?
Your response must be concise. 0.43. What is the ratio of the Expenses (in $) in Bolivia in 2004 to that in 2005?
Give a very brief answer. 0.99. What is the ratio of the Expenses (in $) in Hong Kong in 2004 to that in 2005?
Make the answer very short. 1.02. What is the ratio of the Expenses (in $) in Sri Lanka in 2004 to that in 2005?
Offer a very short reply. 0.77. What is the ratio of the Expenses (in $) of Denmark in 2004 to that in 2006?
Provide a short and direct response. 0.96. What is the ratio of the Expenses (in $) of Sri Lanka in 2004 to that in 2006?
Make the answer very short. 0.61. What is the ratio of the Expenses (in $) in Bolivia in 2004 to that in 2007?
Your answer should be compact. 0.92. What is the ratio of the Expenses (in $) in Denmark in 2004 to that in 2007?
Provide a succinct answer. 0.86. What is the ratio of the Expenses (in $) of Hong Kong in 2004 to that in 2007?
Give a very brief answer. 0.95. What is the ratio of the Expenses (in $) of Sri Lanka in 2004 to that in 2007?
Provide a succinct answer. 0.5. What is the ratio of the Expenses (in $) in Bolivia in 2005 to that in 2006?
Offer a very short reply. 1.02. What is the ratio of the Expenses (in $) of Denmark in 2005 to that in 2006?
Offer a terse response. 0.97. What is the ratio of the Expenses (in $) of Sri Lanka in 2005 to that in 2006?
Offer a very short reply. 0.79. What is the ratio of the Expenses (in $) in Bolivia in 2005 to that in 2007?
Provide a short and direct response. 0.93. What is the ratio of the Expenses (in $) of Denmark in 2005 to that in 2007?
Make the answer very short. 0.86. What is the ratio of the Expenses (in $) of Hong Kong in 2005 to that in 2007?
Offer a very short reply. 0.93. What is the ratio of the Expenses (in $) in Sri Lanka in 2005 to that in 2007?
Your answer should be compact. 0.65. What is the ratio of the Expenses (in $) in Bolivia in 2006 to that in 2007?
Offer a terse response. 0.92. What is the ratio of the Expenses (in $) of Denmark in 2006 to that in 2007?
Your answer should be compact. 0.89. What is the ratio of the Expenses (in $) in Hong Kong in 2006 to that in 2007?
Provide a succinct answer. 0.95. What is the ratio of the Expenses (in $) of Sri Lanka in 2006 to that in 2007?
Your answer should be very brief. 0.82. What is the difference between the highest and the second highest Expenses (in $) in Bolivia?
Provide a succinct answer. 3.37e+08. What is the difference between the highest and the second highest Expenses (in $) of Denmark?
Offer a very short reply. 8.81e+09. What is the difference between the highest and the second highest Expenses (in $) in Hong Kong?
Keep it short and to the point. 1.84e+09. What is the difference between the highest and the second highest Expenses (in $) in Sri Lanka?
Your answer should be compact. 3.91e+1. What is the difference between the highest and the lowest Expenses (in $) in Bolivia?
Ensure brevity in your answer.  8.69e+08. What is the difference between the highest and the lowest Expenses (in $) in Denmark?
Your answer should be very brief. 1.41e+1. What is the difference between the highest and the lowest Expenses (in $) in Hong Kong?
Offer a terse response. 7.91e+09. What is the difference between the highest and the lowest Expenses (in $) in Sri Lanka?
Give a very brief answer. 1.25e+11. 